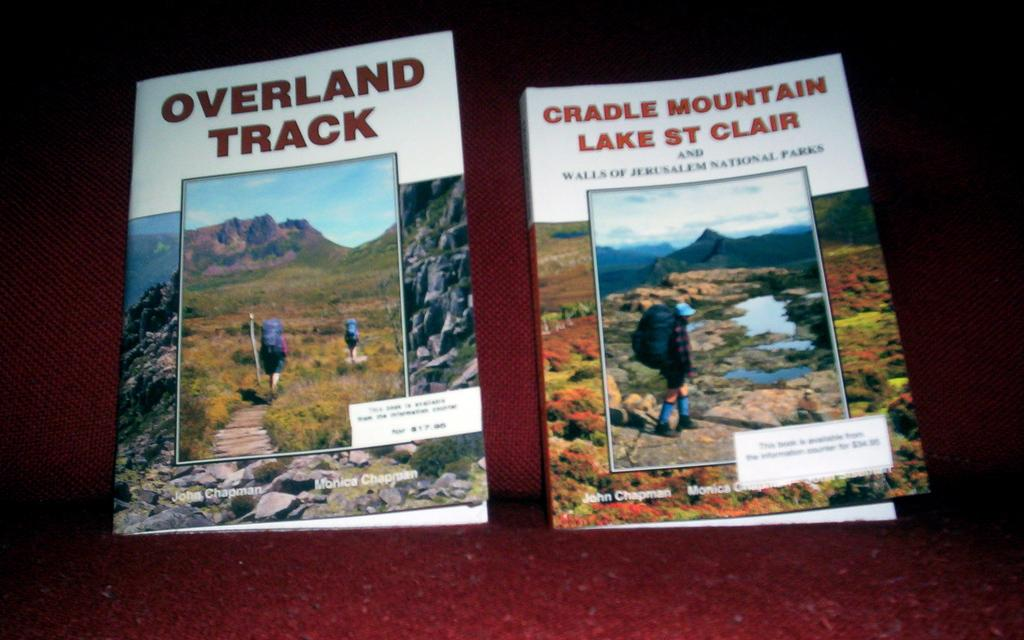<image>
Summarize the visual content of the image. The book "Overland Track" next to the book "Cradle Mountain Lake St Clair". 